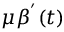Convert formula to latex. <formula><loc_0><loc_0><loc_500><loc_500>\mu \beta ^ { ^ { \prime } } ( t )</formula> 